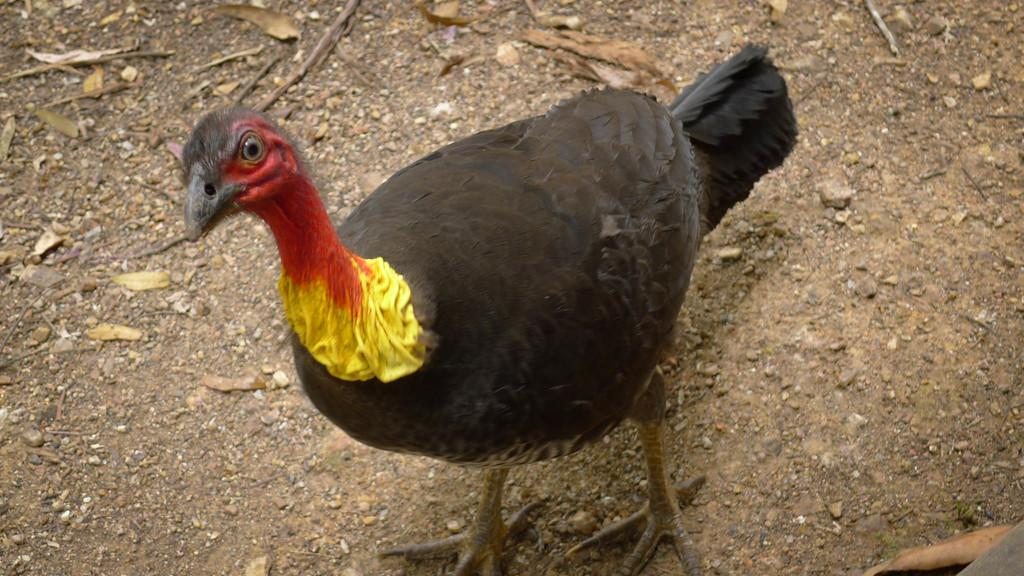What type of animal can be seen in the image? There is a bird in the image. Where is the bird located? The bird is standing on the ground. What else can be seen on the ground in the image? There are stones and dry leaves present on the ground. How does the bird attack the eye in the image? There is no eye present in the image, and the bird is not attacking anything. 